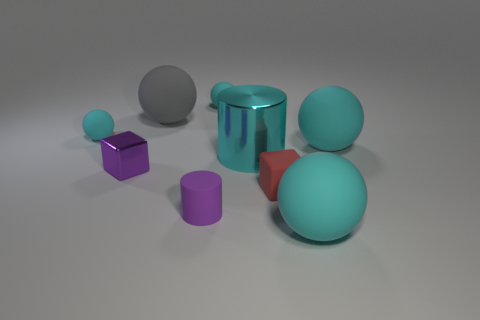Are the large gray sphere and the large cylinder made of the same material?
Provide a short and direct response. No. Are there any purple metal objects of the same shape as the large gray matte thing?
Keep it short and to the point. No. Do the big matte ball left of the big shiny object and the small rubber cylinder have the same color?
Offer a very short reply. No. Is the size of the cyan object that is to the left of the purple matte cylinder the same as the metal thing that is in front of the large cylinder?
Offer a very short reply. Yes. What size is the thing that is the same material as the large cyan cylinder?
Your response must be concise. Small. How many matte things are both on the left side of the cyan shiny cylinder and behind the red rubber object?
Ensure brevity in your answer.  3. What number of objects are either purple metallic things or large cyan matte spheres behind the purple shiny cube?
Provide a succinct answer. 2. There is a tiny metal thing that is the same color as the small cylinder; what is its shape?
Offer a very short reply. Cube. What color is the tiny cube to the right of the large gray rubber ball?
Offer a very short reply. Red. What number of objects are cyan metallic cylinders that are behind the small rubber cylinder or red rubber cubes?
Make the answer very short. 2. 